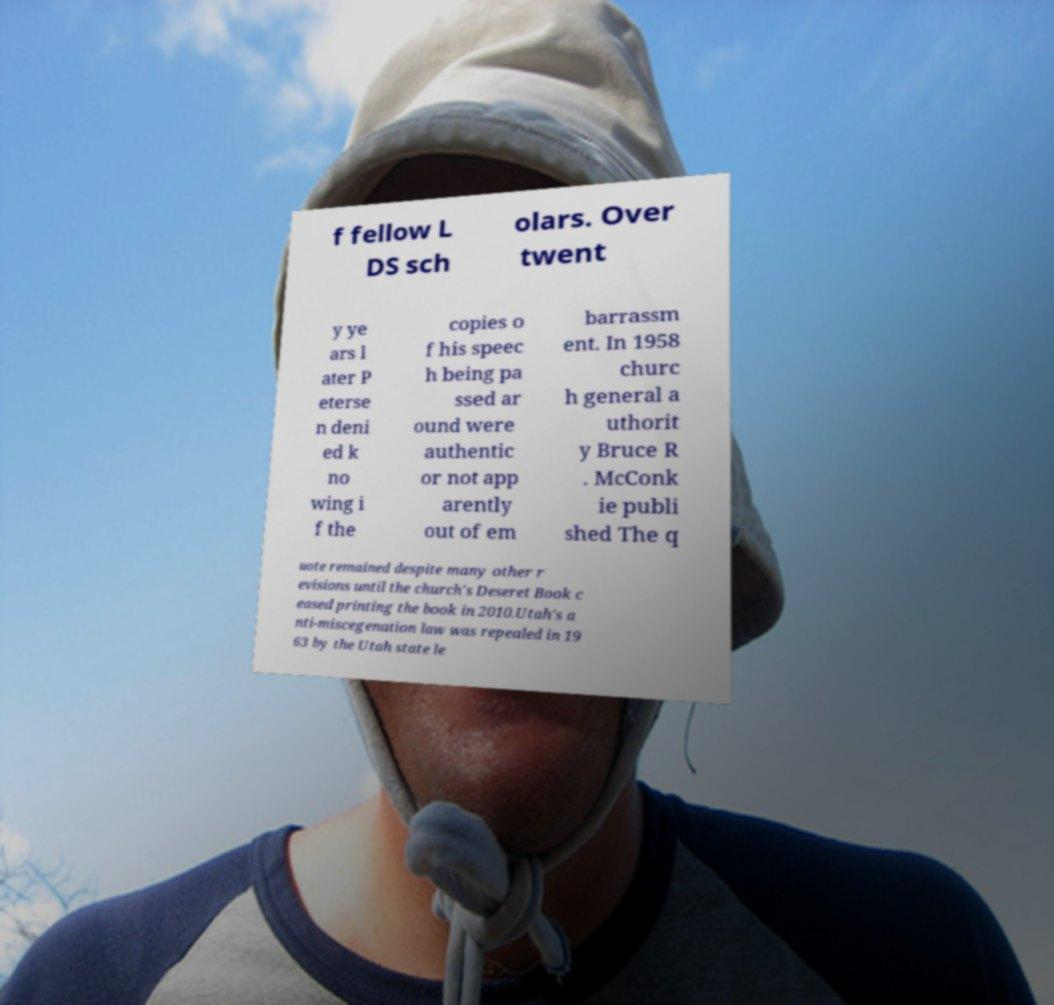Could you extract and type out the text from this image? f fellow L DS sch olars. Over twent y ye ars l ater P eterse n deni ed k no wing i f the copies o f his speec h being pa ssed ar ound were authentic or not app arently out of em barrassm ent. In 1958 churc h general a uthorit y Bruce R . McConk ie publi shed The q uote remained despite many other r evisions until the church's Deseret Book c eased printing the book in 2010.Utah's a nti-miscegenation law was repealed in 19 63 by the Utah state le 